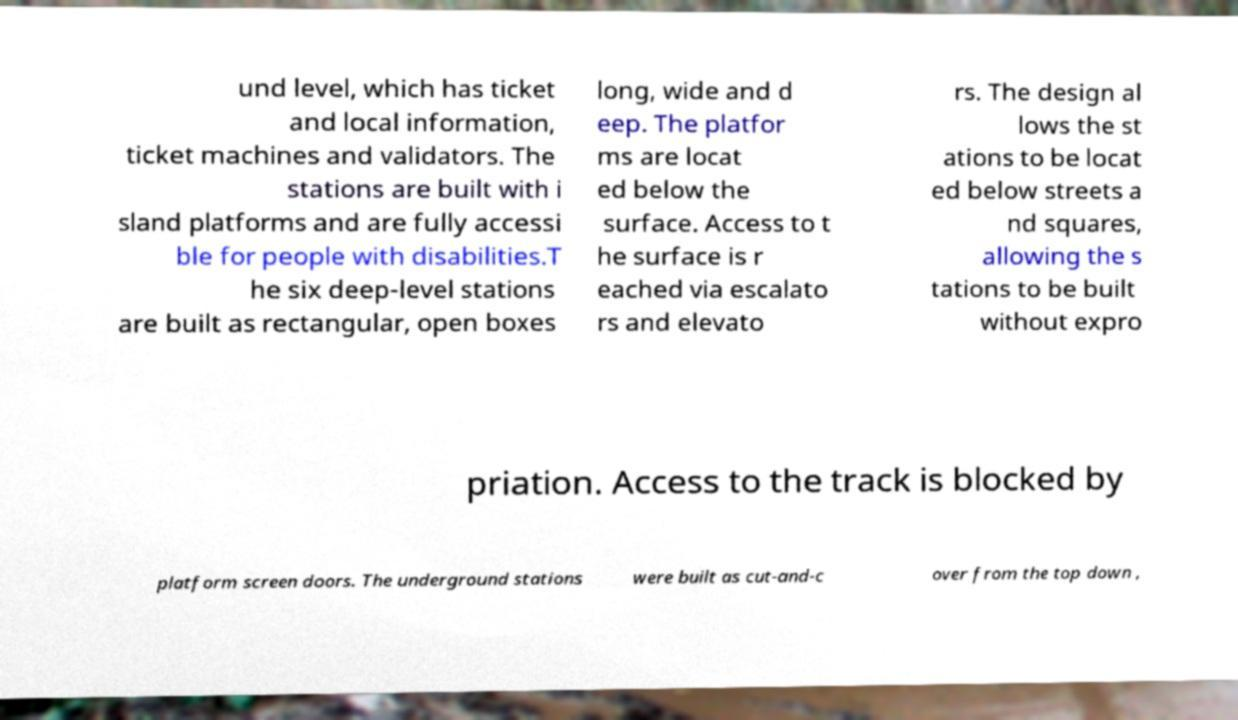Could you extract and type out the text from this image? und level, which has ticket and local information, ticket machines and validators. The stations are built with i sland platforms and are fully accessi ble for people with disabilities.T he six deep-level stations are built as rectangular, open boxes long, wide and d eep. The platfor ms are locat ed below the surface. Access to t he surface is r eached via escalato rs and elevato rs. The design al lows the st ations to be locat ed below streets a nd squares, allowing the s tations to be built without expro priation. Access to the track is blocked by platform screen doors. The underground stations were built as cut-and-c over from the top down , 